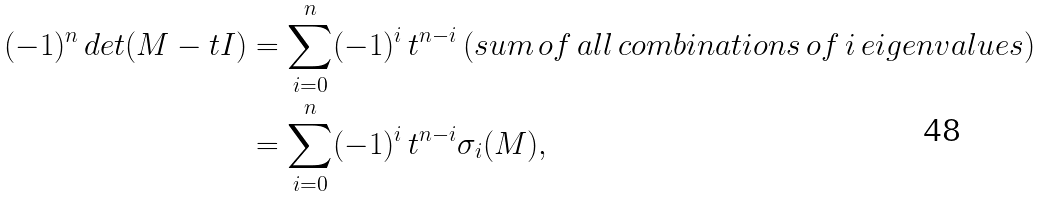Convert formula to latex. <formula><loc_0><loc_0><loc_500><loc_500>( - 1 ) ^ { n } \, d e t ( M - t I ) & = \sum _ { i = 0 } ^ { n } ( - 1 ) ^ { i } \, t ^ { n - i } \, ( s u m \, o f \, a l l \, c o m b i n a t i o n s \, o f \, i \, e i g e n v a l u e s ) \\ & = \sum _ { i = 0 } ^ { n } ( - 1 ) ^ { i } \, t ^ { n - i } \sigma _ { i } ( M ) ,</formula> 